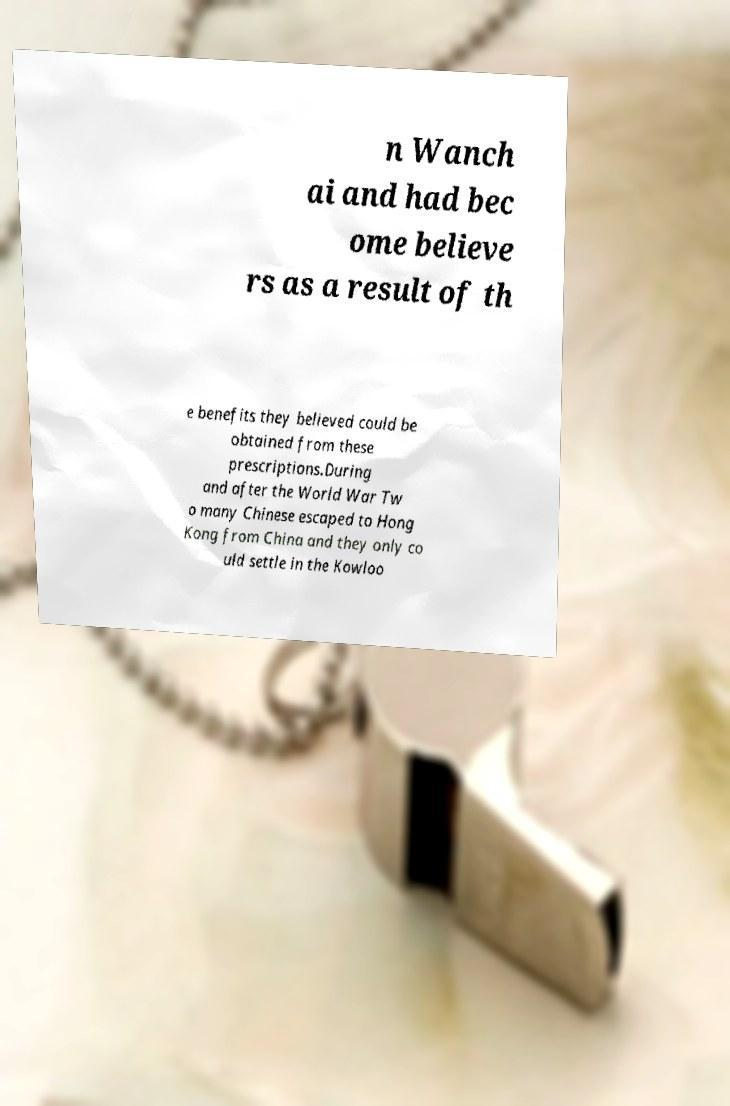I need the written content from this picture converted into text. Can you do that? n Wanch ai and had bec ome believe rs as a result of th e benefits they believed could be obtained from these prescriptions.During and after the World War Tw o many Chinese escaped to Hong Kong from China and they only co uld settle in the Kowloo 